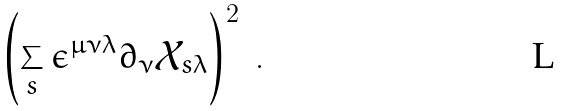<formula> <loc_0><loc_0><loc_500><loc_500>\left ( \sum _ { s } \epsilon ^ { \mu \nu \lambda } \partial _ { \nu } \mathcal { X } _ { s \lambda } \right ) ^ { 2 } \ .</formula> 